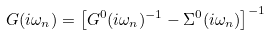<formula> <loc_0><loc_0><loc_500><loc_500>G ( i \omega _ { n } ) = \left [ G ^ { 0 } ( i \omega _ { n } ) ^ { - 1 } - \Sigma ^ { 0 } ( i \omega _ { n } ) \right ] ^ { - 1 }</formula> 